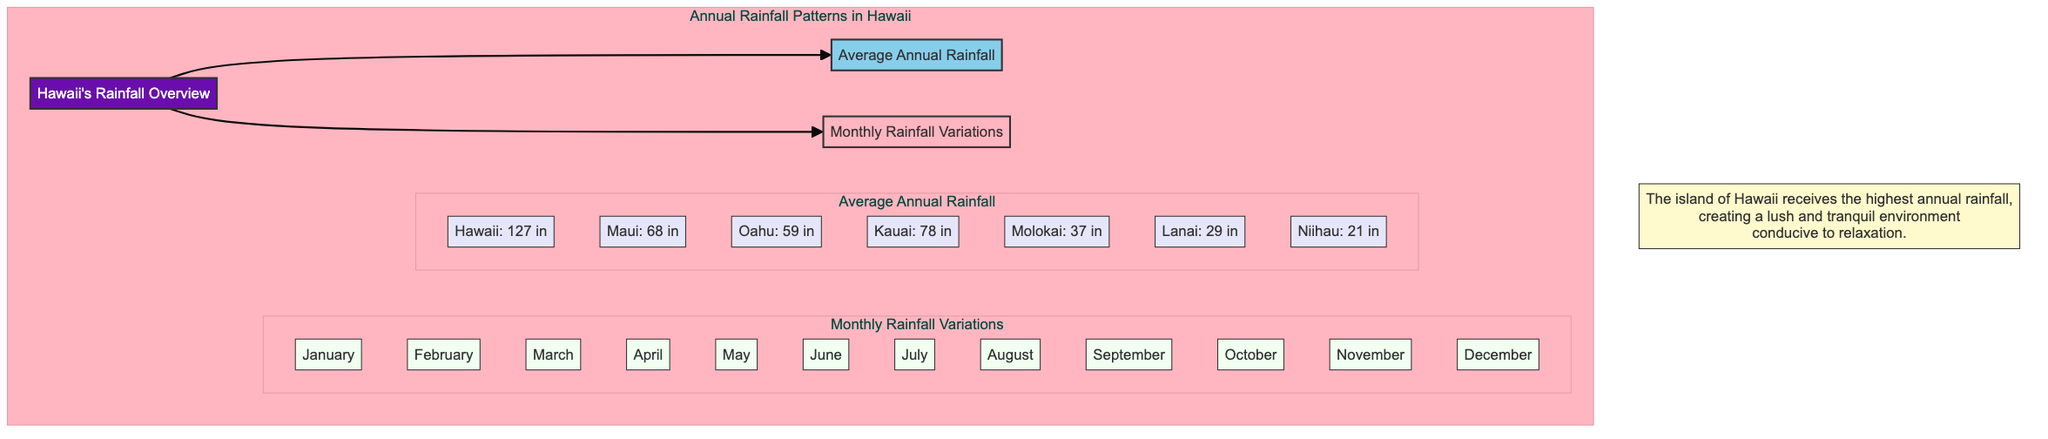What is the highest annual rainfall in Hawaii? The diagram shows that Hawaii receives 127 inches of rainfall annually, which is the highest among the islands listed.
Answer: 127 inches Which island has the least amount of annual rainfall? According to the diagram, Niihau has the least amount of rainfall, recorded at 21 inches annually.
Answer: 21 inches How many islands are listed in the diagram? The diagram includes a total of 7 islands: Hawaii, Maui, Oahu, Kauai, Molokai, Lanai, and Niihau, making the total count 7.
Answer: 7 What is the average annual rainfall for Maui? The diagram indicates that Maui receives an average of 68 inches of rainfall each year.
Answer: 68 inches Which month is mentioned first in the Monthly Rainfall Variations? Looking at the diagram's Monthly Rainfall Variations, January is the first month listed.
Answer: January What is the relationship between Hawaii and the average rainfall information? The diagram shows that Hawaii has the highest average annual rainfall of the listed islands, which emphasizes its lush environment.
Answer: Highest rainfall Which two islands have a combined total of annual rainfall that exceeds 100 inches? By combining Hawaii's 127 inches and Kauai's 78 inches, their total is 205 inches, which exceeds 100 inches.
Answer: Hawaii and Kauai What color represents the rainfall overview in the diagram? The diagram indicates that the rainfall overview is represented with a shade of purple, specifically filled with the code #6A0DAD.
Answer: Purple Which island follows Molokai in the list of average annual rainfall? The diagram shows that Lanai follows Molokai, coming after it in the average annual rainfall section.
Answer: Lanai What color scheme is used to highlight the different months in the diagram? The months of rainfall are highlighted in a light green shade, specifically #F0FFF0, indicating their important role in annual rainfall variation.
Answer: Light green 